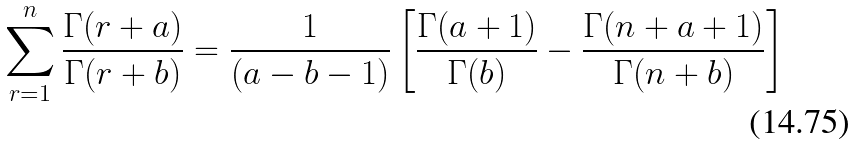<formula> <loc_0><loc_0><loc_500><loc_500>\sum _ { r = 1 } ^ { n } \frac { \Gamma ( r + a ) } { \Gamma ( r + b ) } = \frac { 1 } { ( a - b - 1 ) } \left [ \frac { \Gamma ( a + 1 ) } { \Gamma ( b ) } - \frac { \Gamma ( n + a + 1 ) } { \Gamma ( n + b ) } \right ]</formula> 